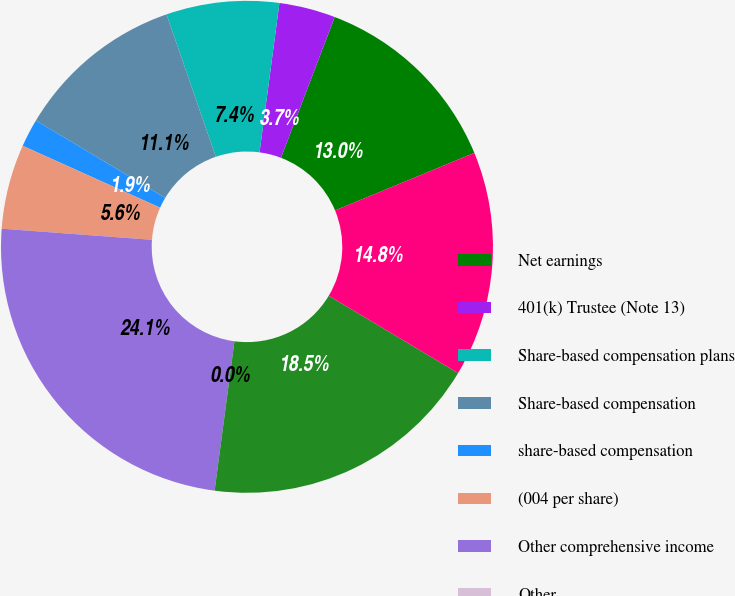Convert chart. <chart><loc_0><loc_0><loc_500><loc_500><pie_chart><fcel>Net earnings<fcel>401(k) Trustee (Note 13)<fcel>Share-based compensation plans<fcel>Share-based compensation<fcel>share-based compensation<fcel>(004 per share)<fcel>Other comprehensive income<fcel>Other<fcel>Acquisitions<fcel>(022 per share)<nl><fcel>12.96%<fcel>3.7%<fcel>7.41%<fcel>11.11%<fcel>1.85%<fcel>5.56%<fcel>24.07%<fcel>0.0%<fcel>18.52%<fcel>14.81%<nl></chart> 